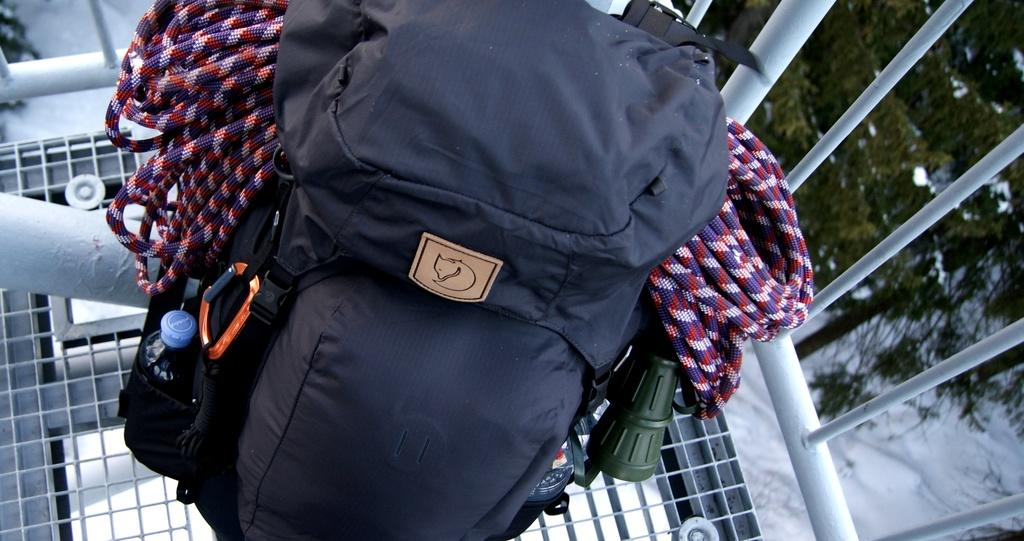What type of bag is visible in the image? There is a travel bag in the image. What items are inside the travel bag? Climbing ropes are present in the travel bag. What can be seen on the left side of the image? There is a bottle on the left side of the image. What type of natural scenery is visible on the right side of the image? Trees are visible on the right side of the image. Can you see a ray swimming in the image? There is no ray present in the image; it features a travel bag with climbing ropes, a bottle, and trees. 